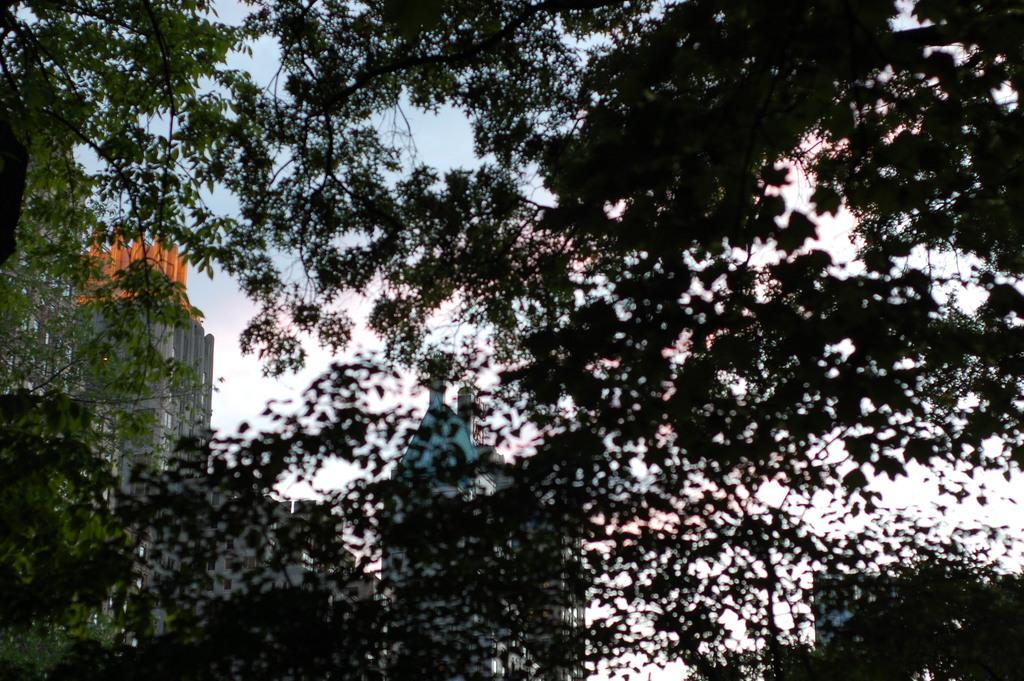How would you summarize this image in a sentence or two? In this picture I can see buildings, trees and a blue cloudy sky. 